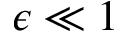Convert formula to latex. <formula><loc_0><loc_0><loc_500><loc_500>\epsilon \ll 1</formula> 